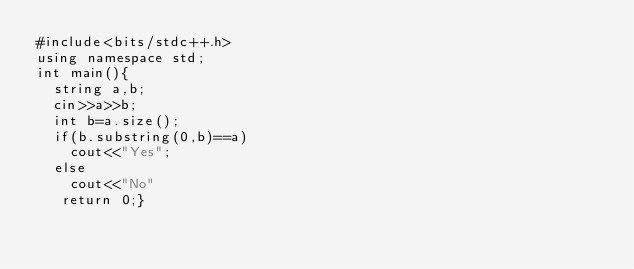<code> <loc_0><loc_0><loc_500><loc_500><_C++_>#include<bits/stdc++.h>
using namespace std;
int main(){
  string a,b;
  cin>>a>>b;
  int b=a.size();
  if(b.substring(0,b)==a)
    cout<<"Yes";
  else
    cout<<"No"
   return 0;}</code> 